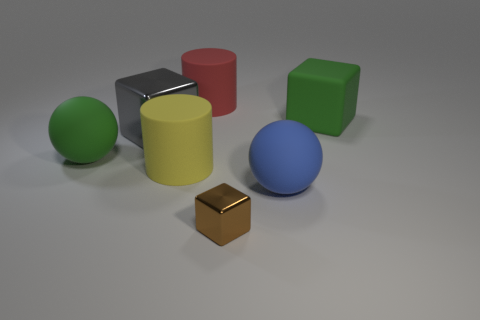Is there anything else that has the same size as the brown thing?
Keep it short and to the point. No. Is there a green block that is to the right of the green thing that is in front of the gray metal object?
Offer a very short reply. Yes. There is a gray object that is the same size as the green rubber sphere; what is it made of?
Provide a succinct answer. Metal. Is there a blue matte cube of the same size as the red matte cylinder?
Your response must be concise. No. What is the material of the cylinder behind the large yellow thing?
Offer a terse response. Rubber. Is the green thing that is on the left side of the big yellow thing made of the same material as the big red object?
Give a very brief answer. Yes. What shape is the red thing that is the same size as the green matte cube?
Offer a terse response. Cylinder. How many other shiny things are the same color as the large metallic object?
Give a very brief answer. 0. Is the number of green rubber objects that are behind the big gray metallic object less than the number of objects that are behind the tiny brown thing?
Your answer should be very brief. Yes. There is a big gray shiny cube; are there any gray metal blocks in front of it?
Give a very brief answer. No. 